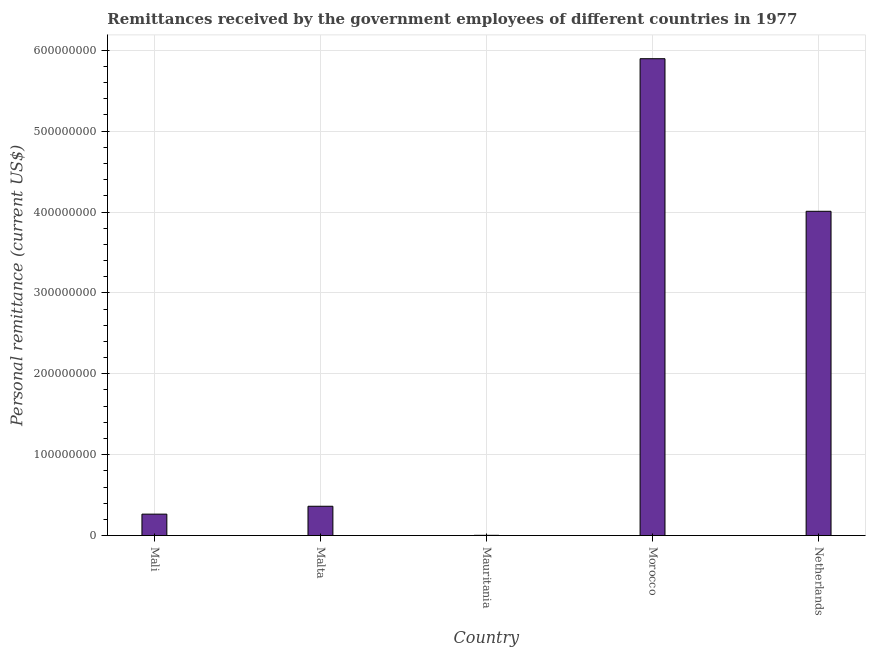Does the graph contain grids?
Provide a succinct answer. Yes. What is the title of the graph?
Keep it short and to the point. Remittances received by the government employees of different countries in 1977. What is the label or title of the X-axis?
Provide a short and direct response. Country. What is the label or title of the Y-axis?
Provide a succinct answer. Personal remittance (current US$). What is the personal remittances in Netherlands?
Ensure brevity in your answer.  4.01e+08. Across all countries, what is the maximum personal remittances?
Your answer should be very brief. 5.90e+08. Across all countries, what is the minimum personal remittances?
Keep it short and to the point. 3.07e+05. In which country was the personal remittances maximum?
Offer a very short reply. Morocco. In which country was the personal remittances minimum?
Your answer should be very brief. Mauritania. What is the sum of the personal remittances?
Make the answer very short. 1.05e+09. What is the difference between the personal remittances in Mali and Morocco?
Your response must be concise. -5.63e+08. What is the average personal remittances per country?
Make the answer very short. 2.11e+08. What is the median personal remittances?
Provide a succinct answer. 3.62e+07. What is the ratio of the personal remittances in Malta to that in Mauritania?
Give a very brief answer. 117.97. What is the difference between the highest and the second highest personal remittances?
Keep it short and to the point. 1.89e+08. What is the difference between the highest and the lowest personal remittances?
Make the answer very short. 5.89e+08. How many bars are there?
Your answer should be very brief. 5. How many countries are there in the graph?
Your response must be concise. 5. What is the Personal remittance (current US$) of Mali?
Your response must be concise. 2.65e+07. What is the Personal remittance (current US$) in Malta?
Your response must be concise. 3.62e+07. What is the Personal remittance (current US$) of Mauritania?
Your answer should be compact. 3.07e+05. What is the Personal remittance (current US$) of Morocco?
Give a very brief answer. 5.90e+08. What is the Personal remittance (current US$) in Netherlands?
Provide a short and direct response. 4.01e+08. What is the difference between the Personal remittance (current US$) in Mali and Malta?
Ensure brevity in your answer.  -9.73e+06. What is the difference between the Personal remittance (current US$) in Mali and Mauritania?
Your answer should be compact. 2.62e+07. What is the difference between the Personal remittance (current US$) in Mali and Morocco?
Offer a very short reply. -5.63e+08. What is the difference between the Personal remittance (current US$) in Mali and Netherlands?
Provide a short and direct response. -3.74e+08. What is the difference between the Personal remittance (current US$) in Malta and Mauritania?
Offer a terse response. 3.59e+07. What is the difference between the Personal remittance (current US$) in Malta and Morocco?
Provide a succinct answer. -5.53e+08. What is the difference between the Personal remittance (current US$) in Malta and Netherlands?
Provide a short and direct response. -3.65e+08. What is the difference between the Personal remittance (current US$) in Mauritania and Morocco?
Ensure brevity in your answer.  -5.89e+08. What is the difference between the Personal remittance (current US$) in Mauritania and Netherlands?
Provide a succinct answer. -4.01e+08. What is the difference between the Personal remittance (current US$) in Morocco and Netherlands?
Provide a succinct answer. 1.89e+08. What is the ratio of the Personal remittance (current US$) in Mali to that in Malta?
Offer a terse response. 0.73. What is the ratio of the Personal remittance (current US$) in Mali to that in Mauritania?
Your response must be concise. 86.28. What is the ratio of the Personal remittance (current US$) in Mali to that in Morocco?
Keep it short and to the point. 0.04. What is the ratio of the Personal remittance (current US$) in Mali to that in Netherlands?
Your response must be concise. 0.07. What is the ratio of the Personal remittance (current US$) in Malta to that in Mauritania?
Offer a very short reply. 117.97. What is the ratio of the Personal remittance (current US$) in Malta to that in Morocco?
Offer a very short reply. 0.06. What is the ratio of the Personal remittance (current US$) in Malta to that in Netherlands?
Ensure brevity in your answer.  0.09. What is the ratio of the Personal remittance (current US$) in Mauritania to that in Morocco?
Your response must be concise. 0. What is the ratio of the Personal remittance (current US$) in Mauritania to that in Netherlands?
Ensure brevity in your answer.  0. What is the ratio of the Personal remittance (current US$) in Morocco to that in Netherlands?
Ensure brevity in your answer.  1.47. 